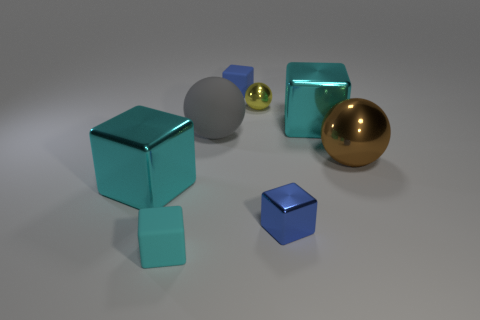How many cyan cubes must be subtracted to get 1 cyan cubes? 2 Add 1 blue matte things. How many objects exist? 9 Subtract all shiny spheres. How many spheres are left? 1 Subtract all gray balls. How many balls are left? 2 Subtract 2 cyan blocks. How many objects are left? 6 Subtract all blocks. How many objects are left? 3 Subtract 4 cubes. How many cubes are left? 1 Subtract all red cubes. Subtract all brown balls. How many cubes are left? 5 Subtract all brown cylinders. How many cyan blocks are left? 3 Subtract all large red metallic objects. Subtract all matte spheres. How many objects are left? 7 